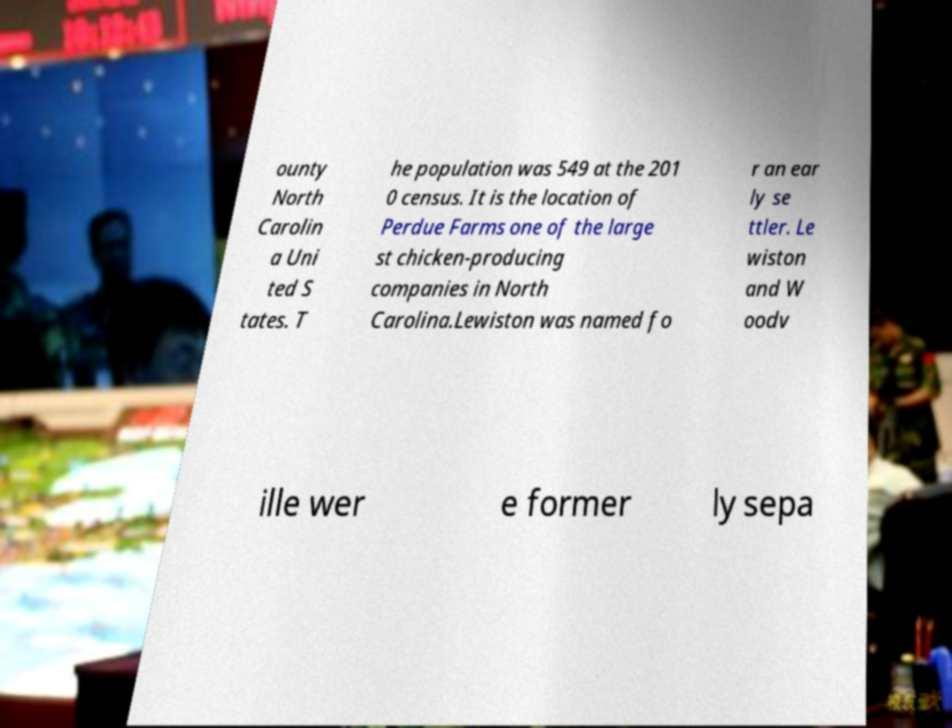What messages or text are displayed in this image? I need them in a readable, typed format. ounty North Carolin a Uni ted S tates. T he population was 549 at the 201 0 census. It is the location of Perdue Farms one of the large st chicken-producing companies in North Carolina.Lewiston was named fo r an ear ly se ttler. Le wiston and W oodv ille wer e former ly sepa 